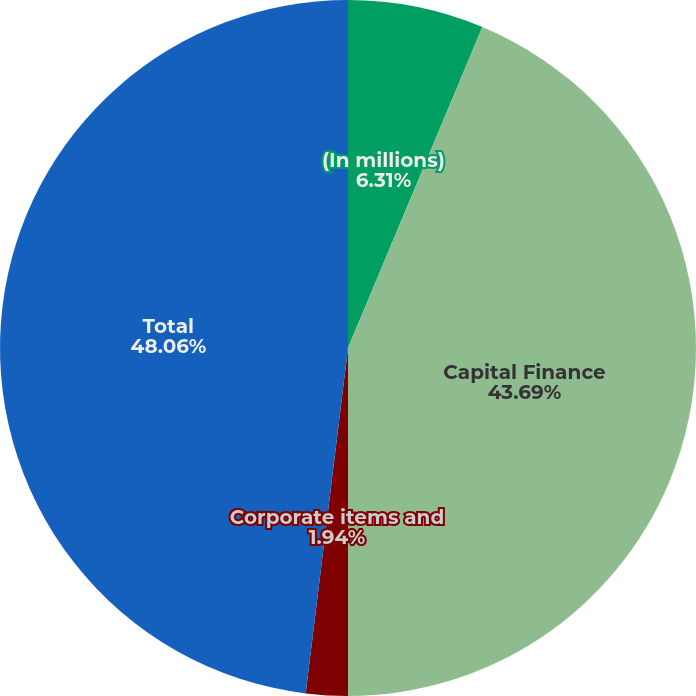<chart> <loc_0><loc_0><loc_500><loc_500><pie_chart><fcel>(In millions)<fcel>Capital Finance<fcel>Corporate items and<fcel>Total<nl><fcel>6.31%<fcel>43.69%<fcel>1.94%<fcel>48.06%<nl></chart> 